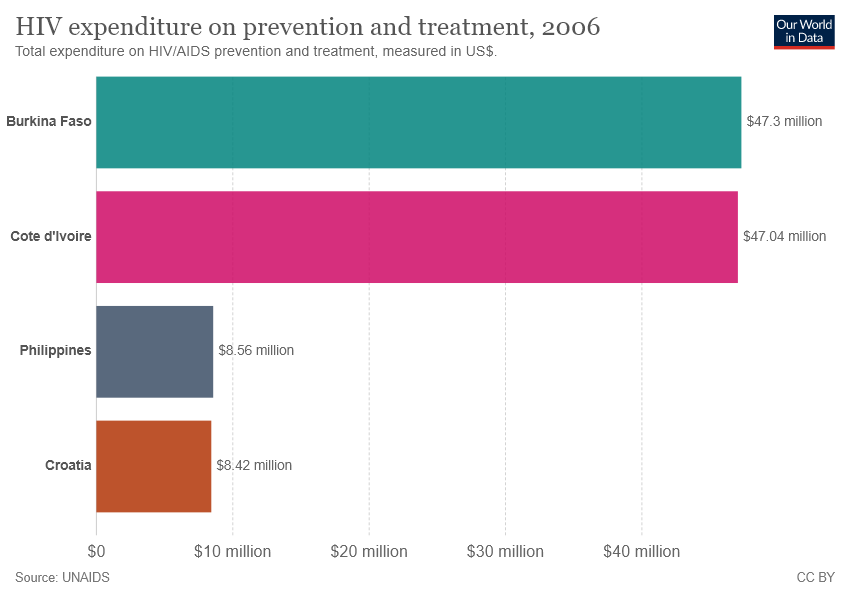List a handful of essential elements in this visual. The total of Croatia and the Philippines is 16.98. The bar representing Croatia is brown. 